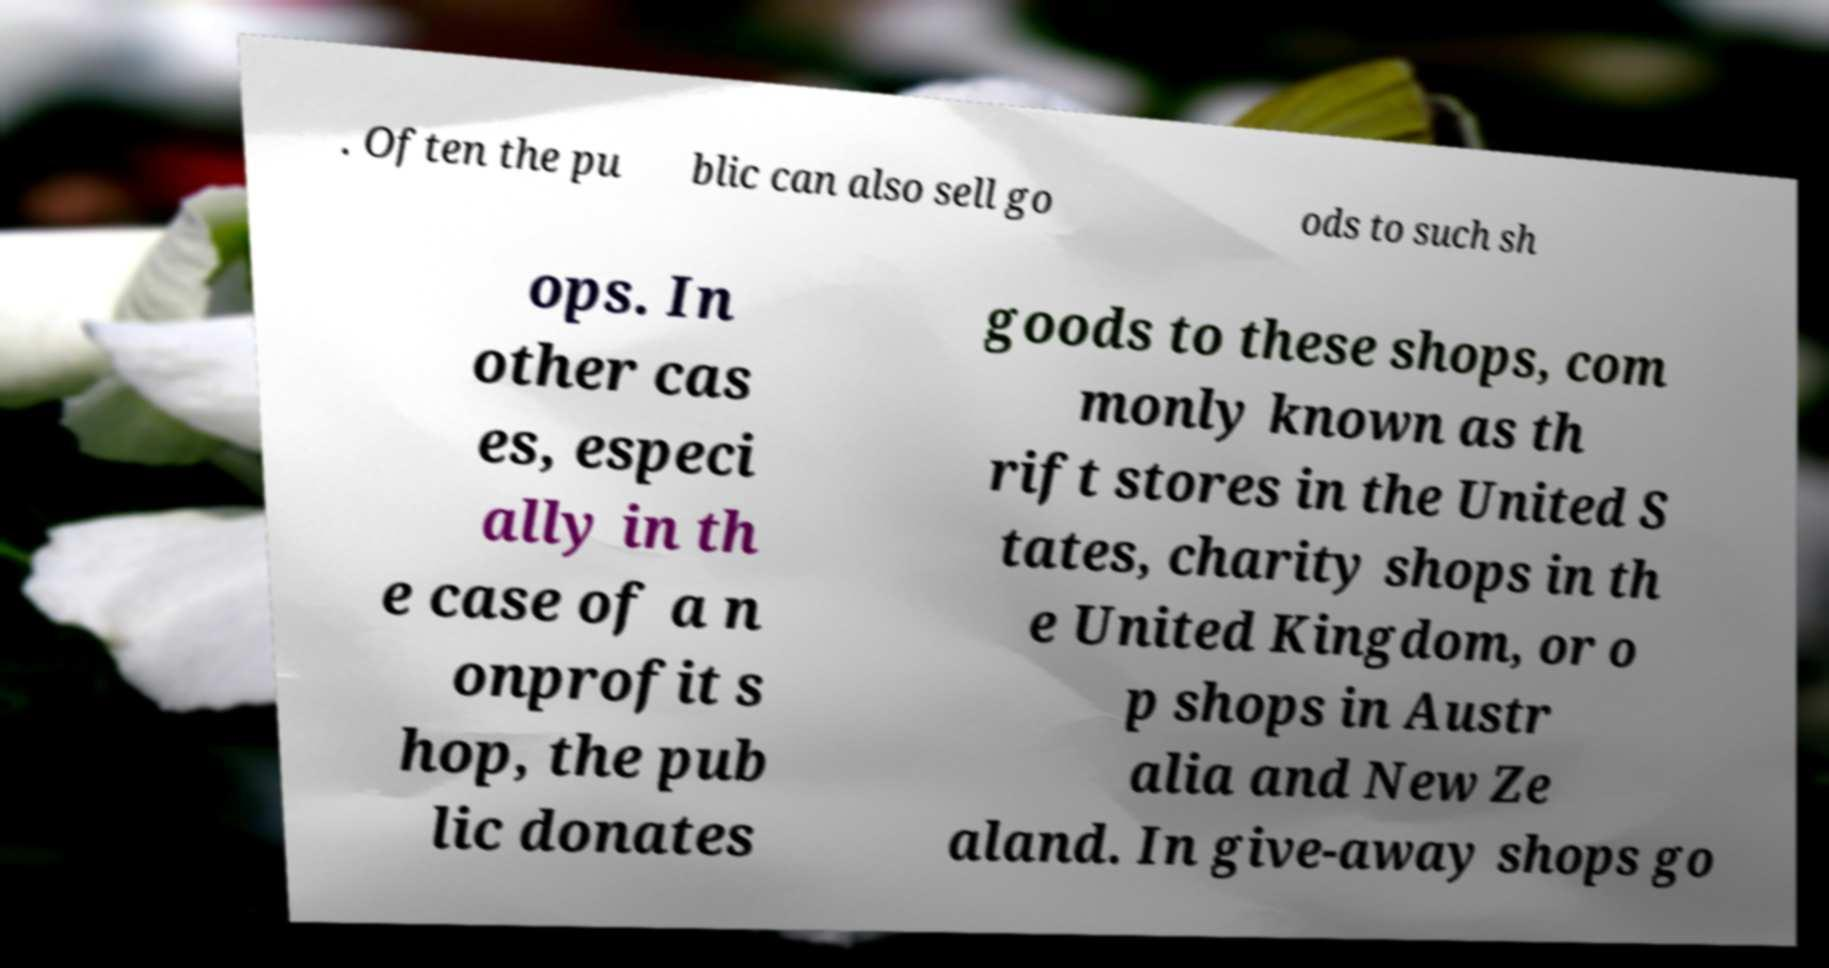Could you assist in decoding the text presented in this image and type it out clearly? . Often the pu blic can also sell go ods to such sh ops. In other cas es, especi ally in th e case of a n onprofit s hop, the pub lic donates goods to these shops, com monly known as th rift stores in the United S tates, charity shops in th e United Kingdom, or o p shops in Austr alia and New Ze aland. In give-away shops go 